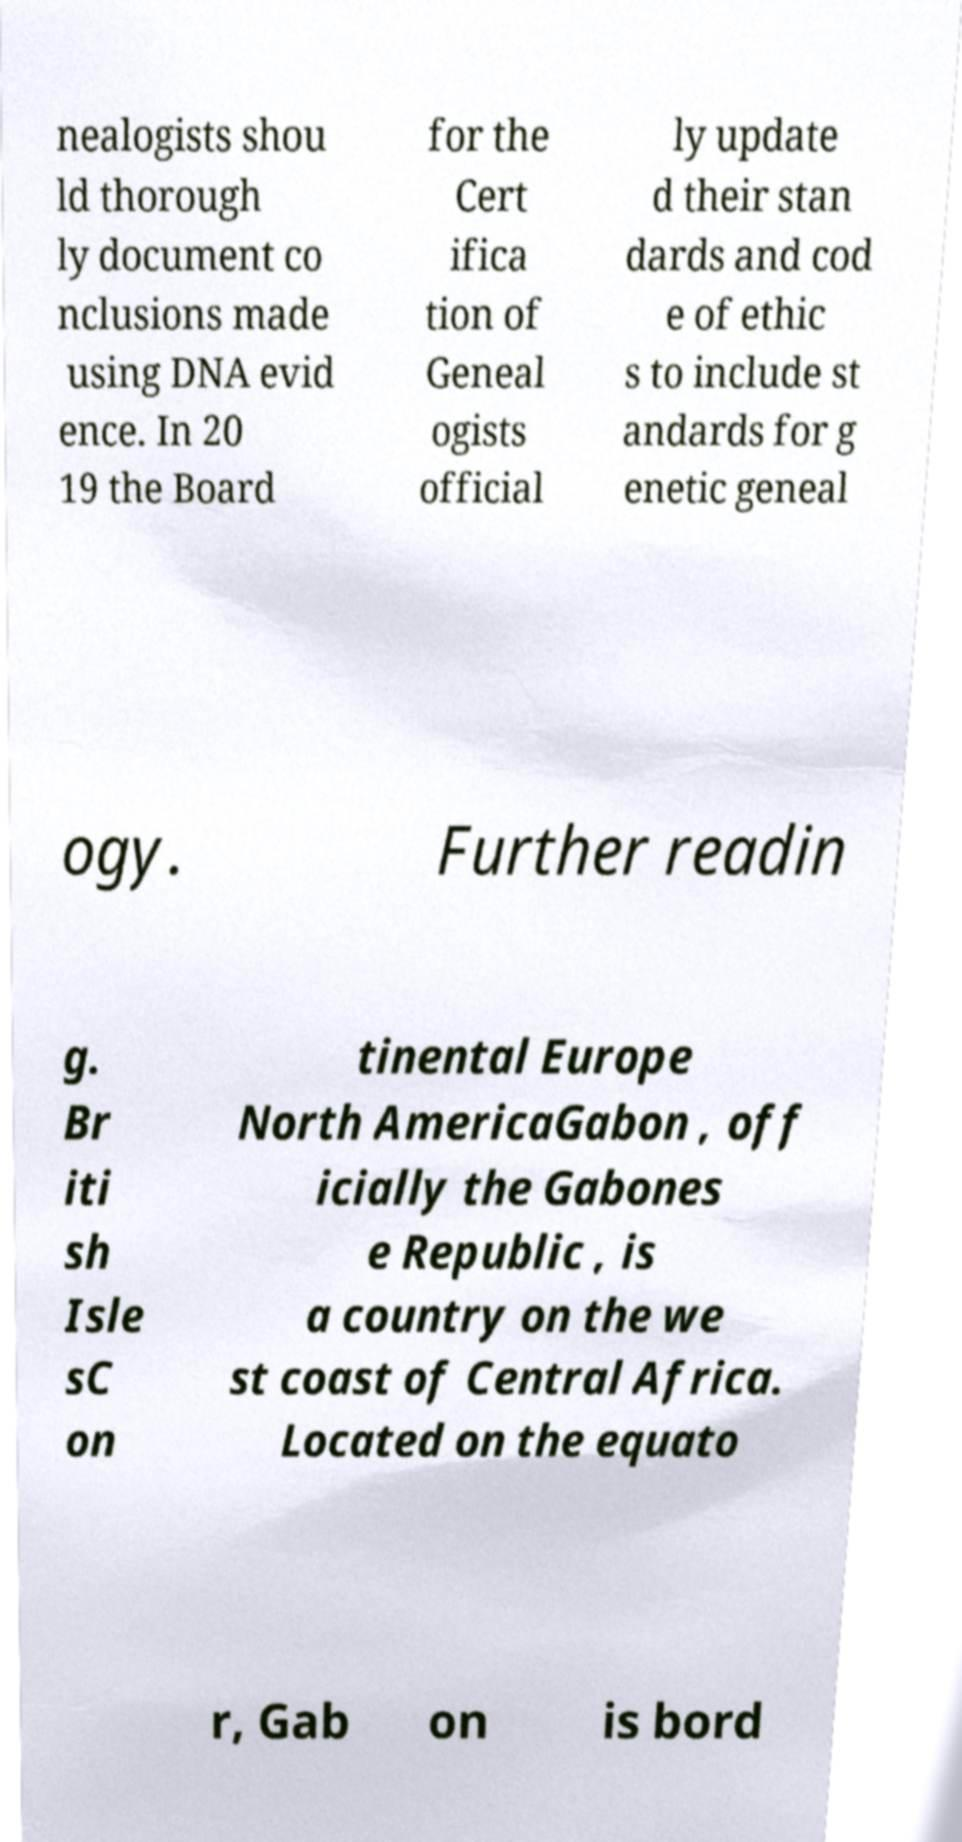What messages or text are displayed in this image? I need them in a readable, typed format. nealogists shou ld thorough ly document co nclusions made using DNA evid ence. In 20 19 the Board for the Cert ifica tion of Geneal ogists official ly update d their stan dards and cod e of ethic s to include st andards for g enetic geneal ogy. Further readin g. Br iti sh Isle sC on tinental Europe North AmericaGabon , off icially the Gabones e Republic , is a country on the we st coast of Central Africa. Located on the equato r, Gab on is bord 